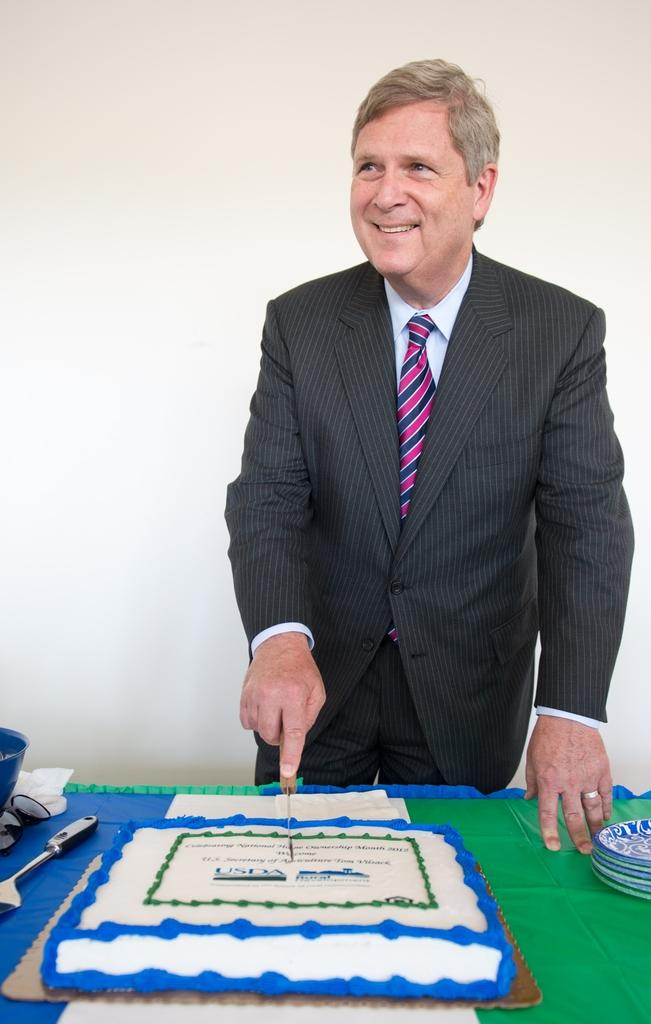What is the person in the image doing? The person is cutting a cake. Where is the cake located in the image? The cake is on a table. What other items can be seen on the table? There are goggles, plates, and a ladle on the table. What is the person's position in the image? The person is standing. What language is the person speaking in the image? There is no indication of the person speaking in the image, so we cannot determine the language. 